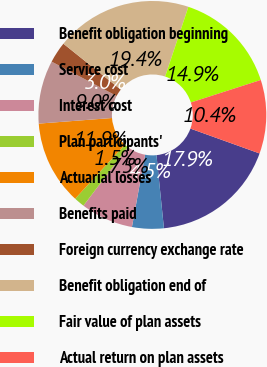Convert chart to OTSL. <chart><loc_0><loc_0><loc_500><loc_500><pie_chart><fcel>Benefit obligation beginning<fcel>Service cost<fcel>Interest cost<fcel>Plan participants'<fcel>Actuarial losses<fcel>Benefits paid<fcel>Foreign currency exchange rate<fcel>Benefit obligation end of<fcel>Fair value of plan assets<fcel>Actual return on plan assets<nl><fcel>17.89%<fcel>4.49%<fcel>7.47%<fcel>1.51%<fcel>11.94%<fcel>8.96%<fcel>3.0%<fcel>19.38%<fcel>14.92%<fcel>10.45%<nl></chart> 